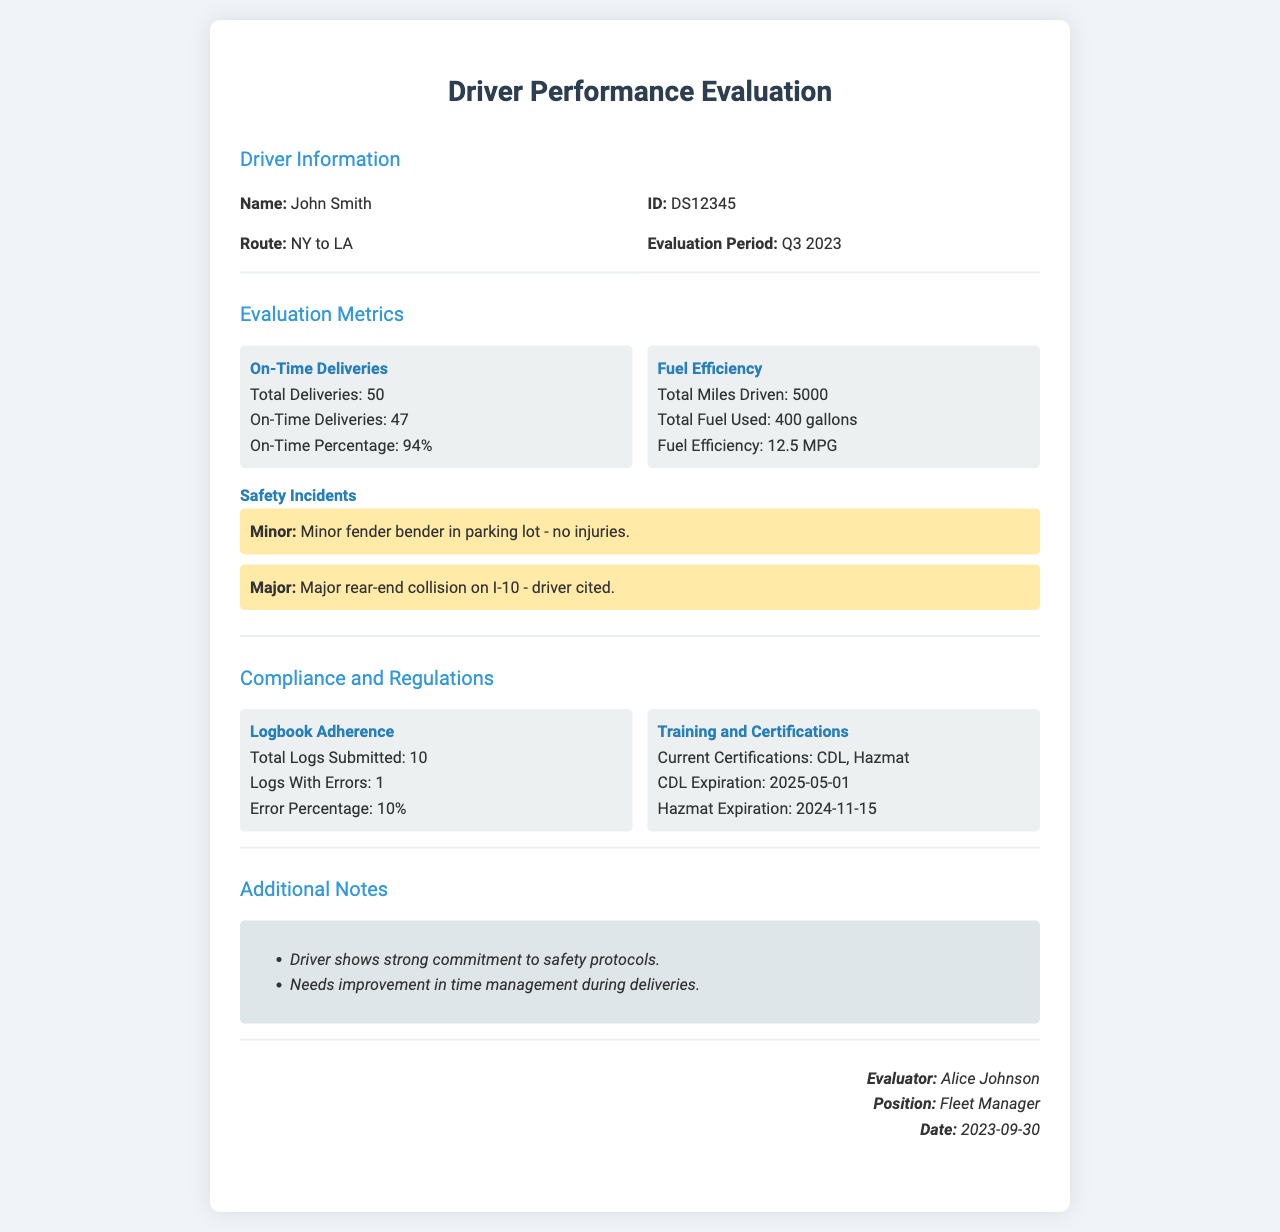What is the name of the driver? The driver's name is listed in the Driver Information section of the document.
Answer: John Smith What is the evaluation period? The evaluation period is specified in the Driver Information section.
Answer: Q3 2023 How many total deliveries were made? The total number of deliveries is provided in the Evaluation Metrics section.
Answer: 50 What was the on-time percentage for deliveries? The on-time percentage is detailed within the on-time deliveries metric.
Answer: 94% What is the total fuel used? The total fuel used is noted under the Fuel Efficiency metric in the document.
Answer: 400 gallons How many safety incidents occurred? The document lists major and minor incidents under the Safety Incidents section.
Answer: 2 What is the error percentage of log submissions? The error percentage is calculated from the Logs With Errors and Total Logs Submitted in the Compliance section.
Answer: 10% What certifications does the driver currently have? The current certifications are listed under Training and Certifications.
Answer: CDL, Hazmat What are the training expiration dates? The expiration dates are provided in the Training and Certifications section of the form.
Answer: CDL: 2025-05-01, Hazmat: 2024-11-15 What is noted about the driver's commitment? This information is captured in the Additional Notes section of the document.
Answer: Strong commitment to safety protocols 